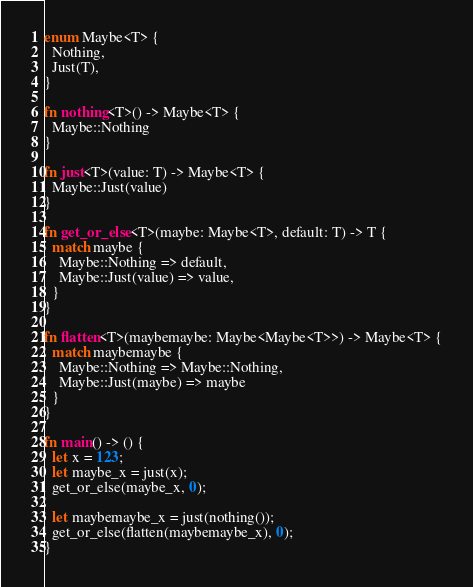Convert code to text. <code><loc_0><loc_0><loc_500><loc_500><_Rust_>enum Maybe<T> {
  Nothing,
  Just(T),
}

fn nothing<T>() -> Maybe<T> {
  Maybe::Nothing
}

fn just<T>(value: T) -> Maybe<T> {
  Maybe::Just(value)
}

fn get_or_else<T>(maybe: Maybe<T>, default: T) -> T {
  match maybe {
    Maybe::Nothing => default,
    Maybe::Just(value) => value,
  }
}

fn flatten<T>(maybemaybe: Maybe<Maybe<T>>) -> Maybe<T> {
  match maybemaybe {
    Maybe::Nothing => Maybe::Nothing,
    Maybe::Just(maybe) => maybe
  }
}

fn main() -> () {
  let x = 123;
  let maybe_x = just(x);
  get_or_else(maybe_x, 0);

  let maybemaybe_x = just(nothing());
  get_or_else(flatten(maybemaybe_x), 0);
}
</code> 